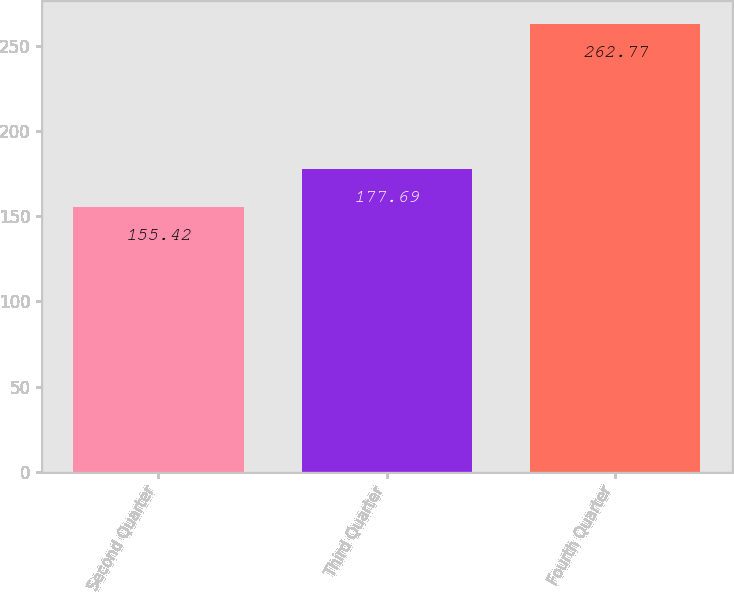Convert chart. <chart><loc_0><loc_0><loc_500><loc_500><bar_chart><fcel>Second Quarter<fcel>Third Quarter<fcel>Fourth Quarter<nl><fcel>155.42<fcel>177.69<fcel>262.77<nl></chart> 